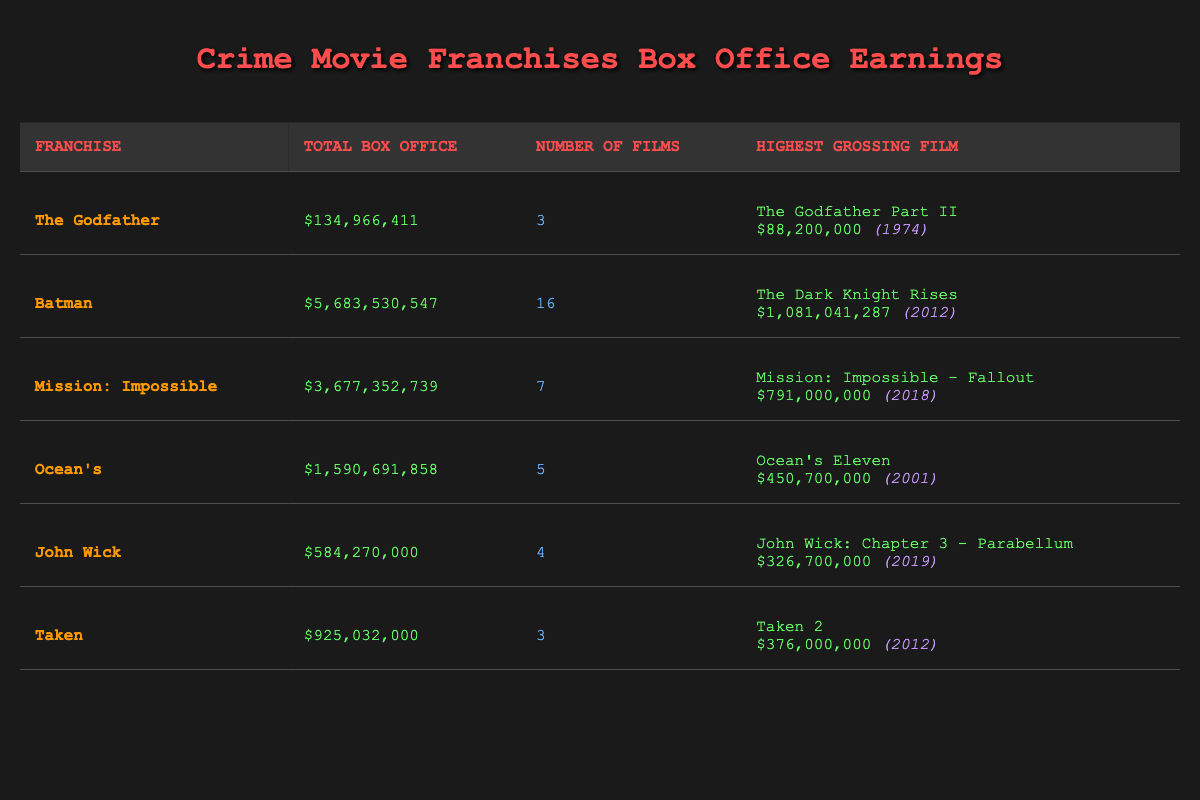What is the highest grossing film in the Batman franchise? The table shows that the highest grossing film in the Batman franchise is "The Dark Knight Rises," with a box office of $1,081,041,287.
Answer: The Dark Knight Rises How many films are there in the Mission: Impossible franchise? According to the table, the Mission: Impossible franchise consists of 7 films.
Answer: 7 Which crime franchise has the lowest total box office earnings? By comparing the total box office earnings listed in the table, "The Godfather" has the lowest total box office earnings of $134,966,411.
Answer: The Godfather Is the highest grossing film of the Ocean's franchise more than 400 million dollars? The table shows that the highest grossing film of the Ocean's franchise, "Ocean's Eleven," has earnings of $450,700,000, which is indeed more than 400 million dollars.
Answer: Yes What is the total box office earnings of the John Wick franchise compared to the Godfather franchise? The total box office earnings for John Wick is $584,270,000, and for The Godfather, it is $134,966,411. The difference is calculated by subtracting these two values: $584,270,000 - $134,966,411 = $449,303,589, meaning John Wick has significantly higher earnings.
Answer: $449,303,589 What is the average total box office earnings across all the crime franchises listed? To find the average, add together the total box office earnings: $134,966,411 + $5,683,530,547 + $3,677,352,739 + $1,590,691,858 + $584,270,000 + $925,032,000 = $7,009,843,555. Now divide by the number of franchises (6): $7,009,843,555 / 6 = approximately $1,168,306,092.
Answer: $1,168,306,092 Has the Taken franchise grossed over 1 billion dollars? The table lists the total box office earnings for the Taken franchise as $925,032,000, which is below 1 billion dollars, thus the statement is false.
Answer: No Which franchise has more films: Ocean's or John Wick? The number of films for Ocean's is 5, while for John Wick it is 4. Comparing the two, Ocean's has more films than John Wick, making the statement true.
Answer: Ocean's has more films 